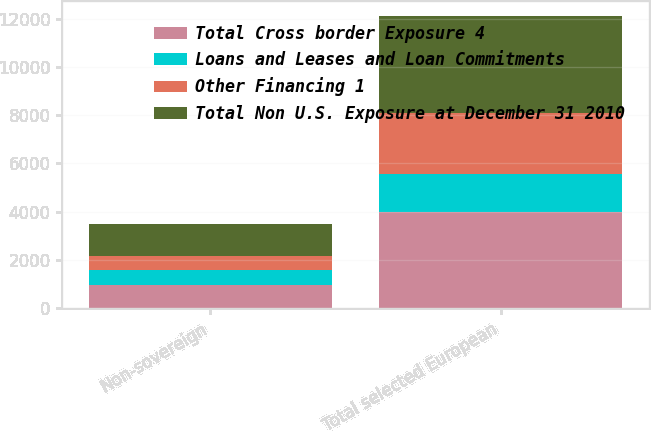Convert chart to OTSL. <chart><loc_0><loc_0><loc_500><loc_500><stacked_bar_chart><ecel><fcel>Non-sovereign<fcel>Total selected European<nl><fcel>Total Cross border Exposure 4<fcel>967<fcel>3993<nl><fcel>Loans and Leases and Loan Commitments<fcel>639<fcel>1586<nl><fcel>Other Financing 1<fcel>560<fcel>2504<nl><fcel>Total Non U.S. Exposure at December 31 2010<fcel>1310<fcel>4038<nl></chart> 